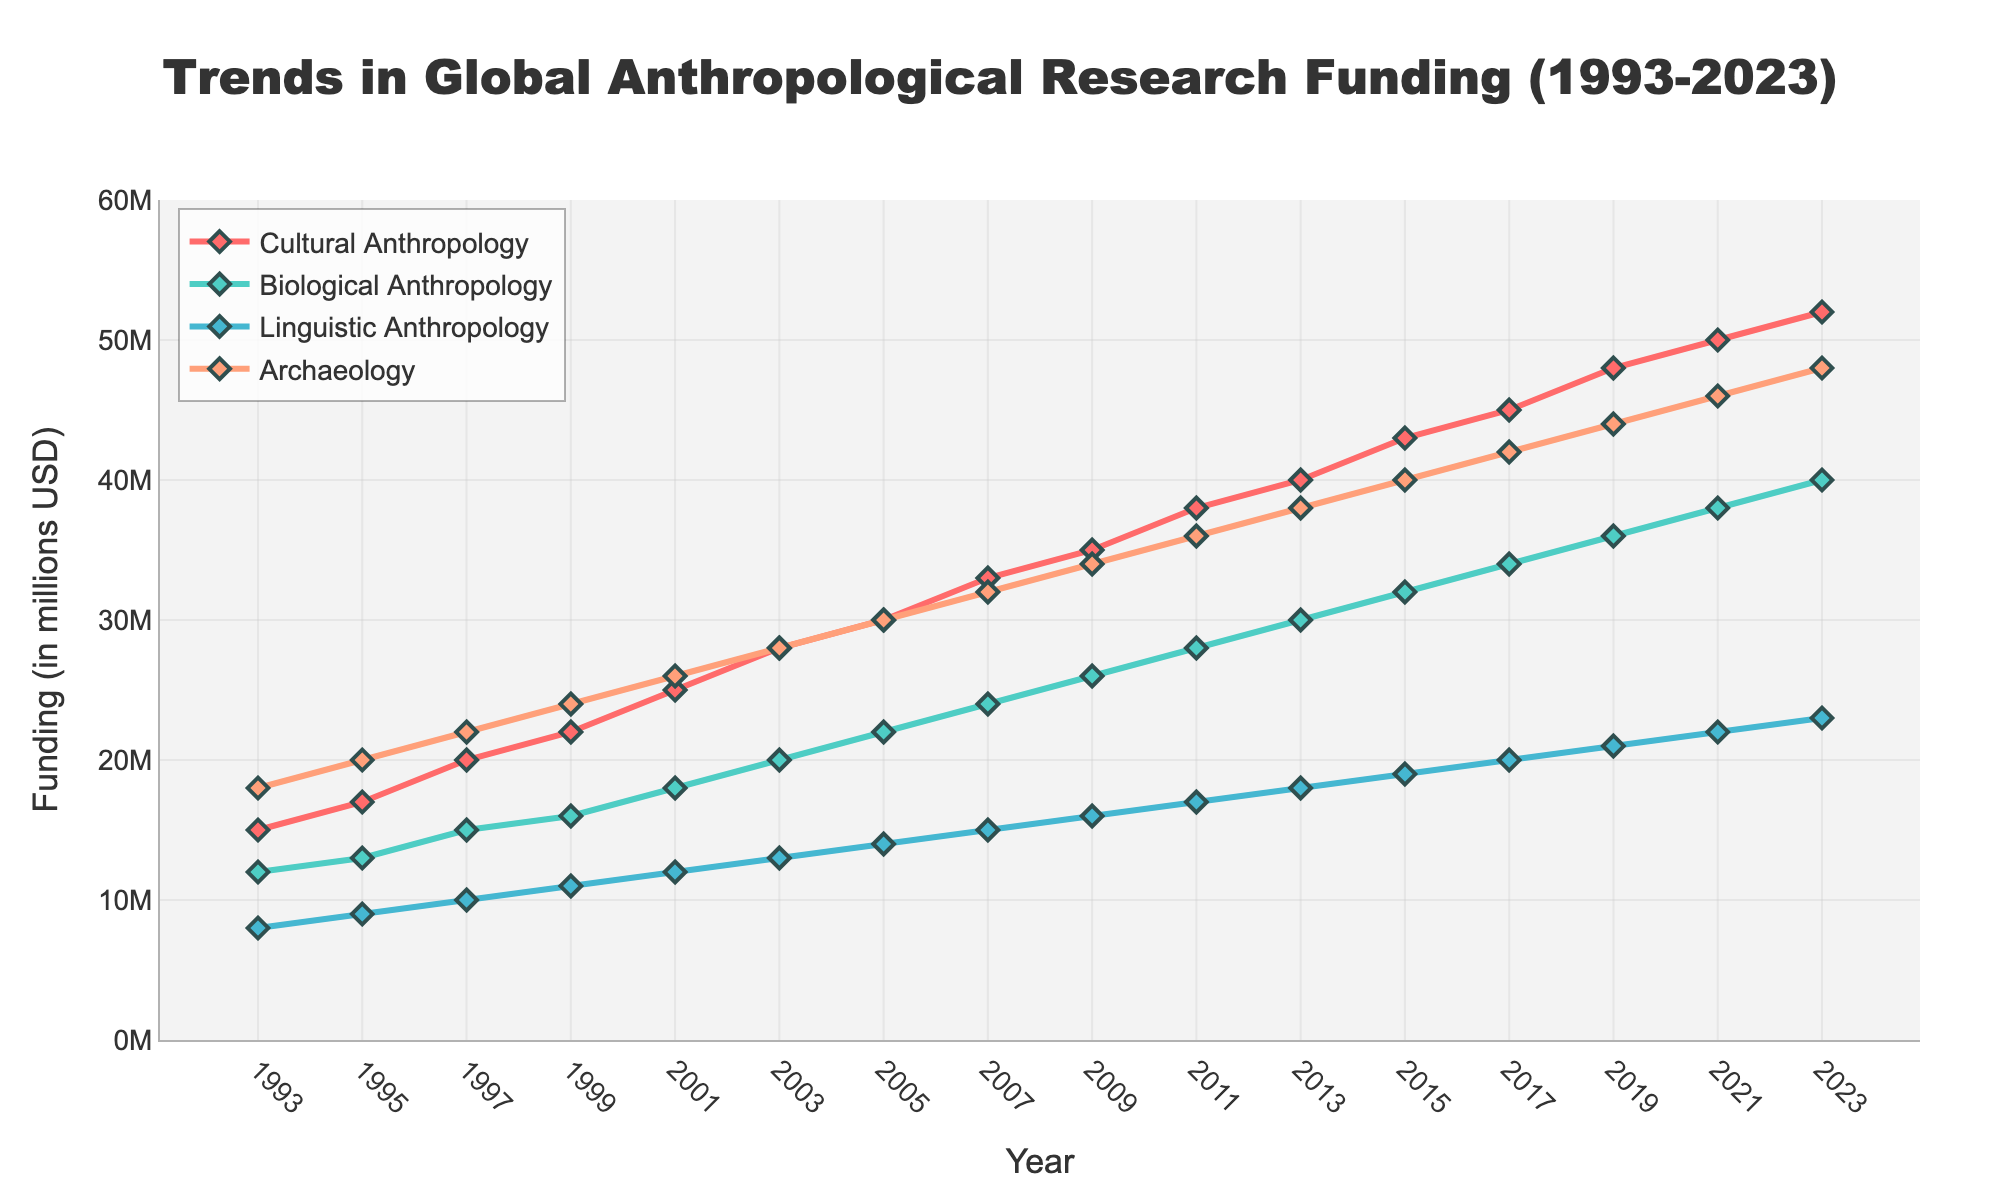What is the funding trend for Cultural Anthropology from 1993 to 2023? To determine the trend, observe the data points for Cultural Anthropology over the years. The funding has consistently increased from 15 million USD in 1993 to 52 million USD in 2023, indicating a positive and steady upward trend.
Answer: Positive upward trend Which subfield has the highest funding in 2023? Check the values for each subfield in 2023. Cultural Anthropology has 52 million USD, Biological Anthropology has 40 million USD, Linguistic Anthropology has 23 million USD, and Archaeology has 48 million USD. Cultural Anthropology has the highest funding.
Answer: Cultural Anthropology How does the funding for Biological Anthropology in 2007 compare to its funding in 2017? Look at the funding amount for Biological Anthropology in 2007 and 2017. In 2007, it was 24 million USD, whereas in 2017, it was 34 million USD. This shows an increase in funding by 10 million USD.
Answer: Increased by 10 million USD What is the difference in funding between Linguistic Anthropology and Archaeology in 2023? Refer to the funding amounts for both subfields in 2023. Linguistic Anthropology has 23 million USD, and Archaeology has 48 million USD. The difference is 48 million USD - 23 million USD = 25 million USD.
Answer: 25 million USD Which subfield had the smallest increase in funding from 1993 to 2023? Calculate the funding increase for each subfield from 1993 to 2023. Cultural Anthropology increased by 37 million USD (52-15), Biological Anthropology by 28 million USD (40-12), Linguistic Anthropology by 15 million USD (23-8), and Archaeology by 30 million USD (48-18). Linguistic Anthropology had the smallest increase.
Answer: Linguistic Anthropology What is the average funding for Archaeology over the last three recorded years (2019, 2021, 2023)? Sum the funding for Archaeology in 2019, 2021, and 2023, then divide by 3. The funding amounts are 44 million USD, 46 million USD, and 48 million USD respectively. The sum is 44 + 46 + 48 = 138 million USD. The average is 138 / 3 = 46 million USD.
Answer: 46 million USD What is the total funding for all subfields in 1999? Add the funding amounts for all subfields in 1999: Cultural Anthropology (22), Biological Anthropology (16), Linguistic Anthropology (11), and Archaeology (24). The total is 22 + 16 + 11 + 24 = 73 million USD.
Answer: 73 million USD Which year saw Biological Anthropology funding surpass 30 million USD for the first time? Look for the first year where the funding for Biological Anthropology is greater than 30 million USD. This occurs in 2013, where the funding is 30 million USD. It surpasses 30 million USD in 2015 with 32 million USD.
Answer: 2015 